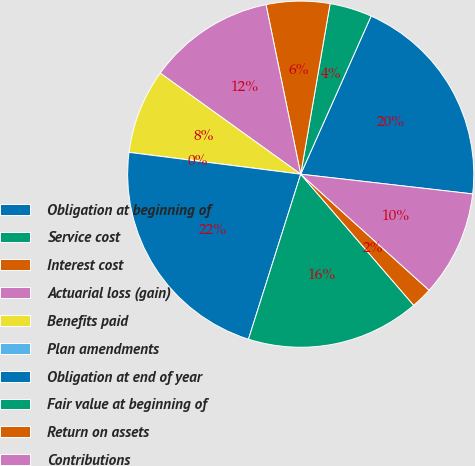Convert chart to OTSL. <chart><loc_0><loc_0><loc_500><loc_500><pie_chart><fcel>Obligation at beginning of<fcel>Service cost<fcel>Interest cost<fcel>Actuarial loss (gain)<fcel>Benefits paid<fcel>Plan amendments<fcel>Obligation at end of year<fcel>Fair value at beginning of<fcel>Return on assets<fcel>Contributions<nl><fcel>20.15%<fcel>3.95%<fcel>5.93%<fcel>11.86%<fcel>7.91%<fcel>0.0%<fcel>22.13%<fcel>16.2%<fcel>1.98%<fcel>9.88%<nl></chart> 